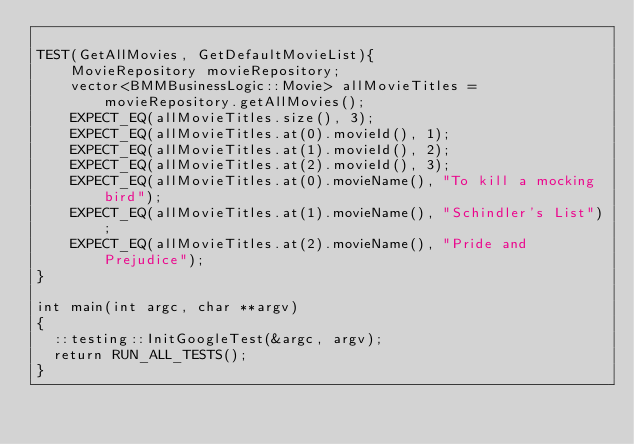Convert code to text. <code><loc_0><loc_0><loc_500><loc_500><_C++_>
TEST(GetAllMovies, GetDefaultMovieList){
    MovieRepository movieRepository;
    vector<BMMBusinessLogic::Movie> allMovieTitles = movieRepository.getAllMovies();
    EXPECT_EQ(allMovieTitles.size(), 3);
    EXPECT_EQ(allMovieTitles.at(0).movieId(), 1);
    EXPECT_EQ(allMovieTitles.at(1).movieId(), 2);
    EXPECT_EQ(allMovieTitles.at(2).movieId(), 3);
    EXPECT_EQ(allMovieTitles.at(0).movieName(), "To kill a mocking bird");
    EXPECT_EQ(allMovieTitles.at(1).movieName(), "Schindler's List");
    EXPECT_EQ(allMovieTitles.at(2).movieName(), "Pride and Prejudice");
}

int main(int argc, char **argv)
{
  ::testing::InitGoogleTest(&argc, argv);
  return RUN_ALL_TESTS();
}
</code> 